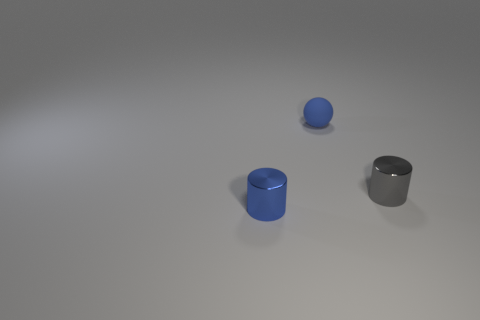Is there anything else that is made of the same material as the ball?
Make the answer very short. No. What shape is the other object that is the same color as the small rubber object?
Ensure brevity in your answer.  Cylinder. What is the object that is both left of the tiny gray cylinder and on the right side of the blue shiny cylinder made of?
Give a very brief answer. Rubber. Is the number of small brown objects less than the number of gray metal cylinders?
Make the answer very short. Yes. There is a gray shiny thing; is its shape the same as the blue thing that is behind the blue cylinder?
Provide a succinct answer. No. The blue rubber thing that is the same size as the gray metallic cylinder is what shape?
Your answer should be compact. Sphere. Does the tiny rubber thing have the same shape as the small blue metal object?
Your response must be concise. No. What number of other small blue objects are the same shape as the small blue metal object?
Offer a very short reply. 0. There is a tiny rubber sphere; how many objects are to the left of it?
Make the answer very short. 1. Does the small shiny cylinder to the right of the tiny ball have the same color as the small ball?
Make the answer very short. No. 